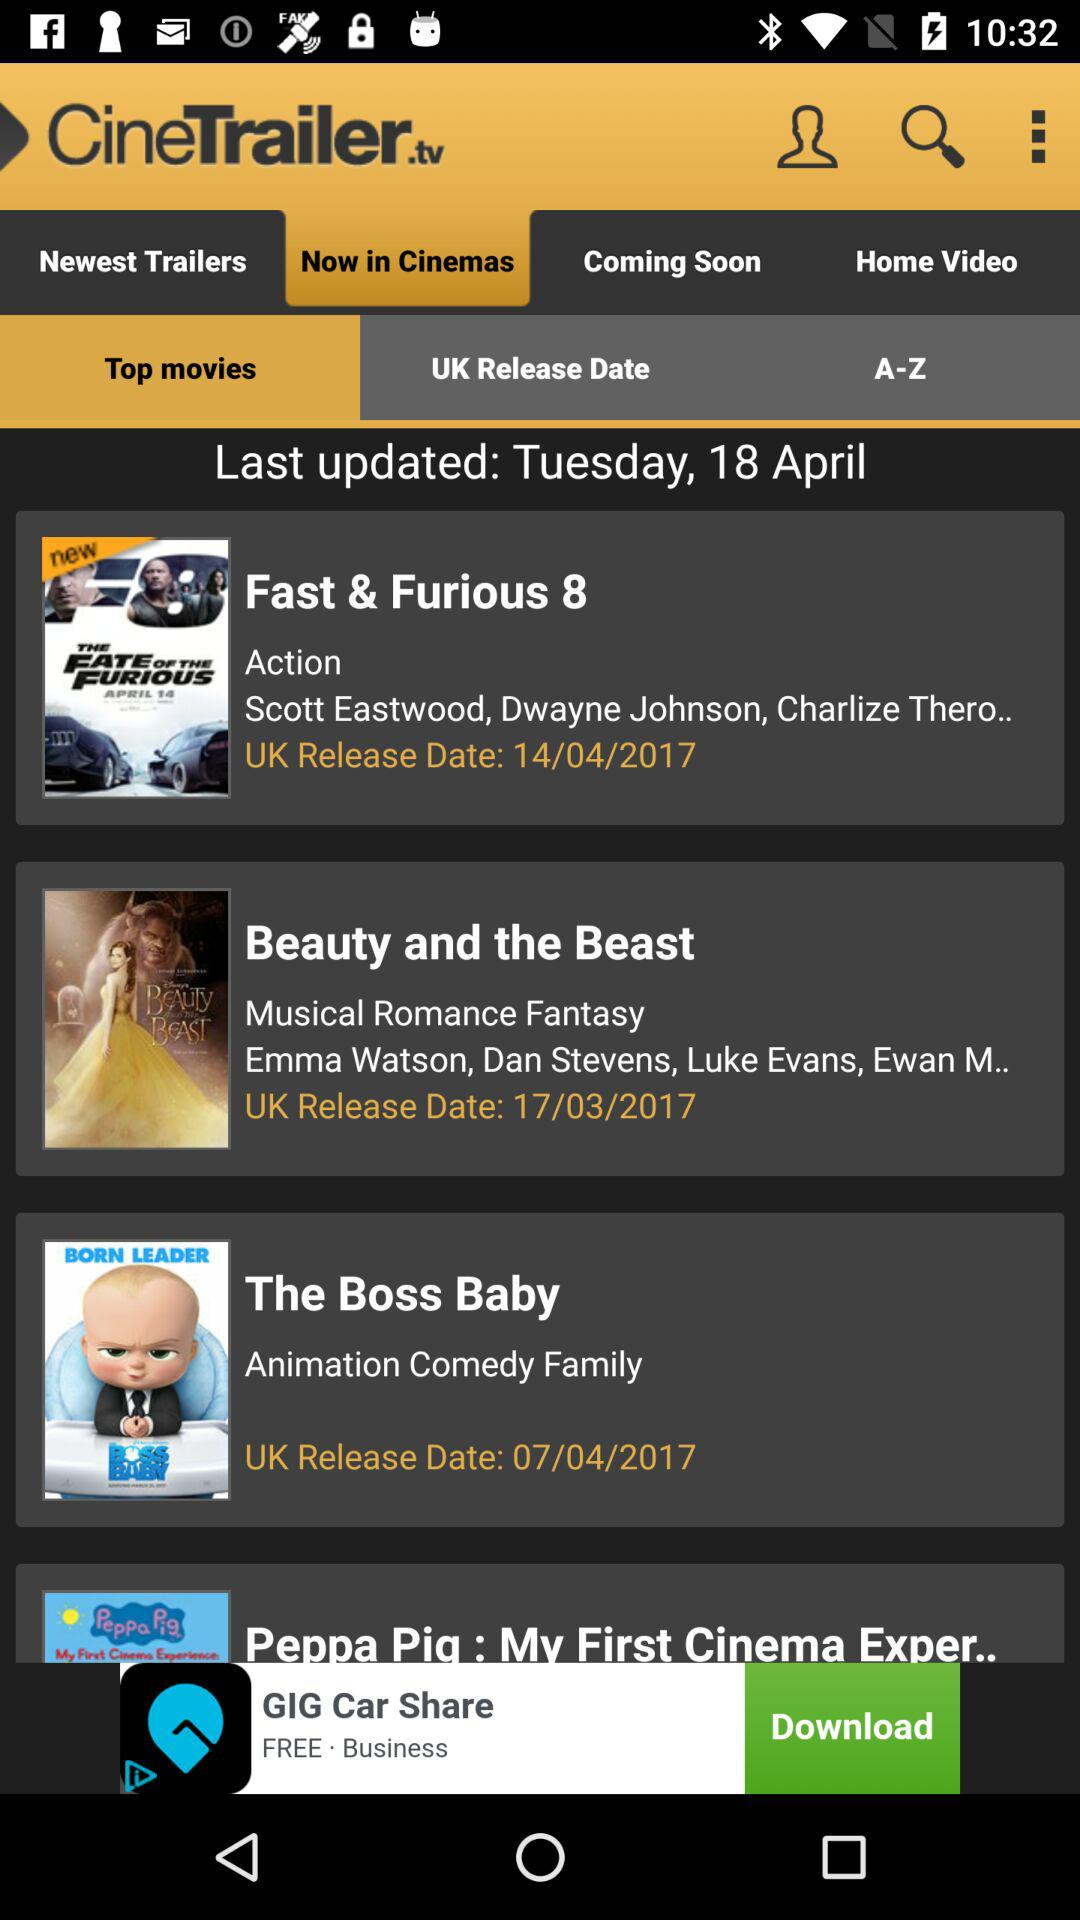On what day was the information in "Top movies" last updated? The information in "Top movies" was last updated on Tuesday. 